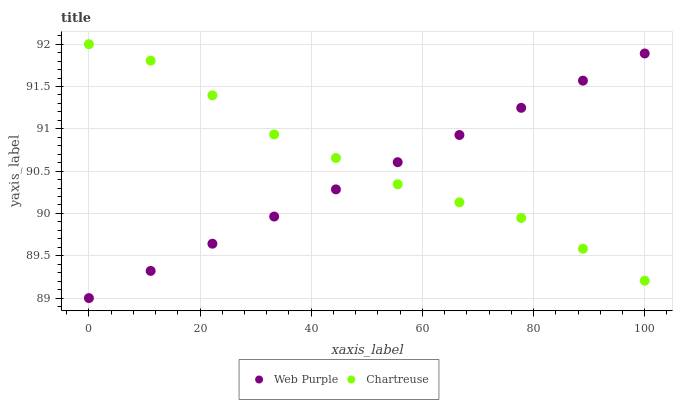Does Web Purple have the minimum area under the curve?
Answer yes or no. Yes. Does Chartreuse have the maximum area under the curve?
Answer yes or no. Yes. Does Chartreuse have the minimum area under the curve?
Answer yes or no. No. Is Web Purple the smoothest?
Answer yes or no. Yes. Is Chartreuse the roughest?
Answer yes or no. Yes. Is Chartreuse the smoothest?
Answer yes or no. No. Does Web Purple have the lowest value?
Answer yes or no. Yes. Does Chartreuse have the lowest value?
Answer yes or no. No. Does Chartreuse have the highest value?
Answer yes or no. Yes. Does Chartreuse intersect Web Purple?
Answer yes or no. Yes. Is Chartreuse less than Web Purple?
Answer yes or no. No. Is Chartreuse greater than Web Purple?
Answer yes or no. No. 